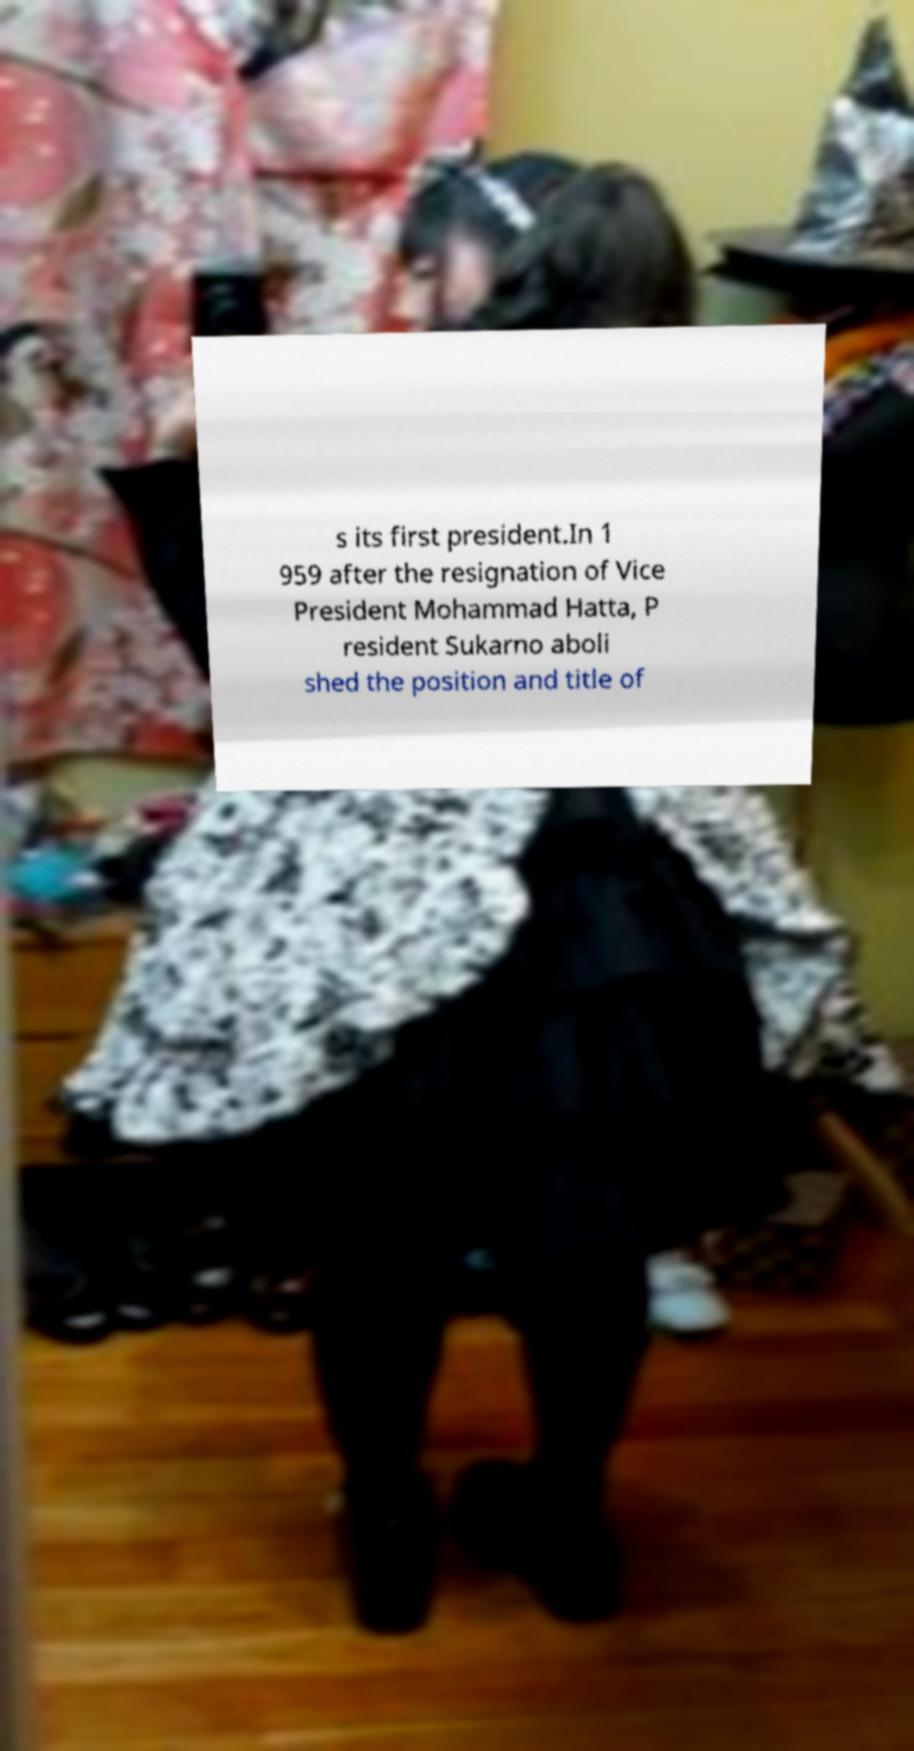Could you extract and type out the text from this image? s its first president.In 1 959 after the resignation of Vice President Mohammad Hatta, P resident Sukarno aboli shed the position and title of 